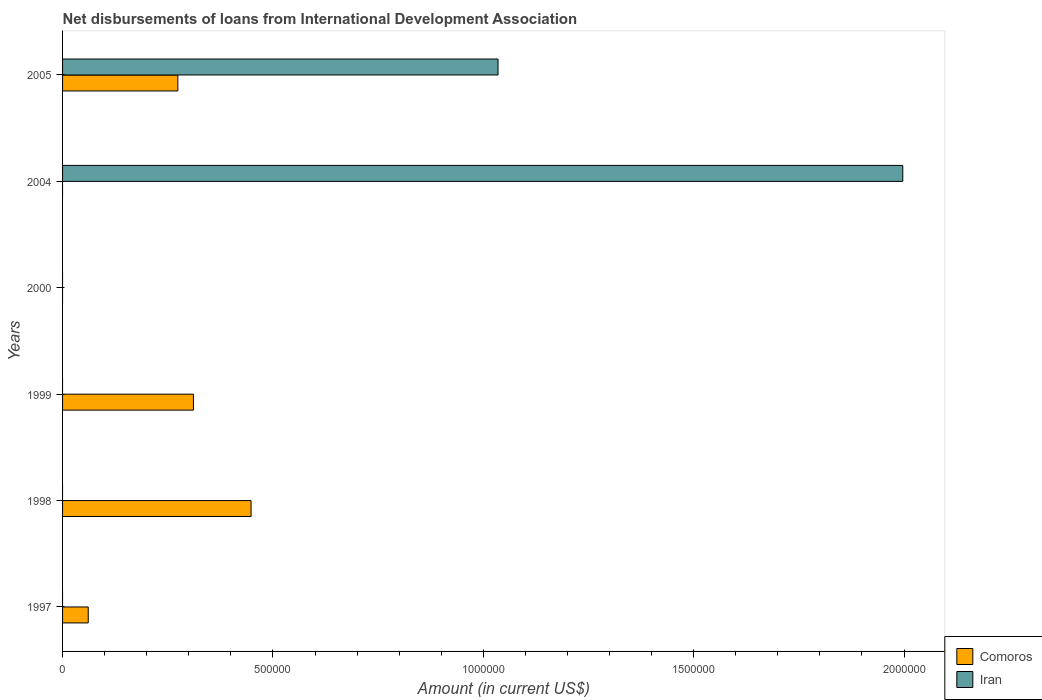How many different coloured bars are there?
Your answer should be compact. 2. How many bars are there on the 4th tick from the top?
Your response must be concise. 1. How many bars are there on the 1st tick from the bottom?
Your answer should be compact. 1. What is the label of the 4th group of bars from the top?
Offer a very short reply. 1999. In how many cases, is the number of bars for a given year not equal to the number of legend labels?
Your answer should be very brief. 5. What is the amount of loans disbursed in Iran in 2000?
Make the answer very short. 0. Across all years, what is the maximum amount of loans disbursed in Iran?
Ensure brevity in your answer.  2.00e+06. Across all years, what is the minimum amount of loans disbursed in Comoros?
Keep it short and to the point. 0. What is the total amount of loans disbursed in Comoros in the graph?
Provide a short and direct response. 1.09e+06. What is the difference between the amount of loans disbursed in Comoros in 1998 and that in 1999?
Offer a terse response. 1.37e+05. What is the difference between the amount of loans disbursed in Iran in 2005 and the amount of loans disbursed in Comoros in 1998?
Make the answer very short. 5.87e+05. What is the average amount of loans disbursed in Iran per year?
Offer a terse response. 5.05e+05. In the year 2005, what is the difference between the amount of loans disbursed in Iran and amount of loans disbursed in Comoros?
Offer a very short reply. 7.61e+05. In how many years, is the amount of loans disbursed in Iran greater than 1300000 US$?
Offer a terse response. 1. What is the ratio of the amount of loans disbursed in Iran in 2004 to that in 2005?
Offer a very short reply. 1.93. What is the difference between the highest and the second highest amount of loans disbursed in Comoros?
Offer a very short reply. 1.37e+05. What is the difference between the highest and the lowest amount of loans disbursed in Comoros?
Offer a very short reply. 4.48e+05. Is the sum of the amount of loans disbursed in Comoros in 1997 and 1998 greater than the maximum amount of loans disbursed in Iran across all years?
Your answer should be very brief. No. How many years are there in the graph?
Provide a succinct answer. 6. What is the difference between two consecutive major ticks on the X-axis?
Your response must be concise. 5.00e+05. What is the title of the graph?
Your answer should be compact. Net disbursements of loans from International Development Association. What is the label or title of the X-axis?
Make the answer very short. Amount (in current US$). What is the Amount (in current US$) in Comoros in 1997?
Your response must be concise. 6.10e+04. What is the Amount (in current US$) in Comoros in 1998?
Your response must be concise. 4.48e+05. What is the Amount (in current US$) of Iran in 1998?
Offer a very short reply. 0. What is the Amount (in current US$) of Comoros in 1999?
Provide a succinct answer. 3.11e+05. What is the Amount (in current US$) of Iran in 1999?
Keep it short and to the point. 0. What is the Amount (in current US$) of Iran in 2000?
Ensure brevity in your answer.  0. What is the Amount (in current US$) of Comoros in 2004?
Provide a succinct answer. 0. What is the Amount (in current US$) in Iran in 2004?
Your answer should be very brief. 2.00e+06. What is the Amount (in current US$) of Comoros in 2005?
Provide a short and direct response. 2.74e+05. What is the Amount (in current US$) of Iran in 2005?
Your answer should be very brief. 1.04e+06. Across all years, what is the maximum Amount (in current US$) of Comoros?
Keep it short and to the point. 4.48e+05. Across all years, what is the maximum Amount (in current US$) of Iran?
Provide a succinct answer. 2.00e+06. Across all years, what is the minimum Amount (in current US$) in Comoros?
Offer a terse response. 0. Across all years, what is the minimum Amount (in current US$) of Iran?
Provide a succinct answer. 0. What is the total Amount (in current US$) of Comoros in the graph?
Provide a succinct answer. 1.09e+06. What is the total Amount (in current US$) of Iran in the graph?
Keep it short and to the point. 3.03e+06. What is the difference between the Amount (in current US$) in Comoros in 1997 and that in 1998?
Provide a short and direct response. -3.87e+05. What is the difference between the Amount (in current US$) in Comoros in 1997 and that in 2005?
Your answer should be very brief. -2.13e+05. What is the difference between the Amount (in current US$) of Comoros in 1998 and that in 1999?
Offer a very short reply. 1.37e+05. What is the difference between the Amount (in current US$) in Comoros in 1998 and that in 2005?
Provide a succinct answer. 1.74e+05. What is the difference between the Amount (in current US$) of Comoros in 1999 and that in 2005?
Make the answer very short. 3.70e+04. What is the difference between the Amount (in current US$) of Iran in 2004 and that in 2005?
Give a very brief answer. 9.62e+05. What is the difference between the Amount (in current US$) of Comoros in 1997 and the Amount (in current US$) of Iran in 2004?
Your answer should be very brief. -1.94e+06. What is the difference between the Amount (in current US$) of Comoros in 1997 and the Amount (in current US$) of Iran in 2005?
Offer a terse response. -9.74e+05. What is the difference between the Amount (in current US$) of Comoros in 1998 and the Amount (in current US$) of Iran in 2004?
Provide a short and direct response. -1.55e+06. What is the difference between the Amount (in current US$) in Comoros in 1998 and the Amount (in current US$) in Iran in 2005?
Provide a succinct answer. -5.87e+05. What is the difference between the Amount (in current US$) of Comoros in 1999 and the Amount (in current US$) of Iran in 2004?
Offer a very short reply. -1.69e+06. What is the difference between the Amount (in current US$) of Comoros in 1999 and the Amount (in current US$) of Iran in 2005?
Your answer should be compact. -7.24e+05. What is the average Amount (in current US$) of Comoros per year?
Give a very brief answer. 1.82e+05. What is the average Amount (in current US$) of Iran per year?
Ensure brevity in your answer.  5.05e+05. In the year 2005, what is the difference between the Amount (in current US$) of Comoros and Amount (in current US$) of Iran?
Make the answer very short. -7.61e+05. What is the ratio of the Amount (in current US$) in Comoros in 1997 to that in 1998?
Offer a terse response. 0.14. What is the ratio of the Amount (in current US$) of Comoros in 1997 to that in 1999?
Give a very brief answer. 0.2. What is the ratio of the Amount (in current US$) of Comoros in 1997 to that in 2005?
Your response must be concise. 0.22. What is the ratio of the Amount (in current US$) in Comoros in 1998 to that in 1999?
Give a very brief answer. 1.44. What is the ratio of the Amount (in current US$) of Comoros in 1998 to that in 2005?
Offer a very short reply. 1.64. What is the ratio of the Amount (in current US$) of Comoros in 1999 to that in 2005?
Ensure brevity in your answer.  1.14. What is the ratio of the Amount (in current US$) of Iran in 2004 to that in 2005?
Ensure brevity in your answer.  1.93. What is the difference between the highest and the second highest Amount (in current US$) in Comoros?
Ensure brevity in your answer.  1.37e+05. What is the difference between the highest and the lowest Amount (in current US$) of Comoros?
Give a very brief answer. 4.48e+05. What is the difference between the highest and the lowest Amount (in current US$) in Iran?
Ensure brevity in your answer.  2.00e+06. 